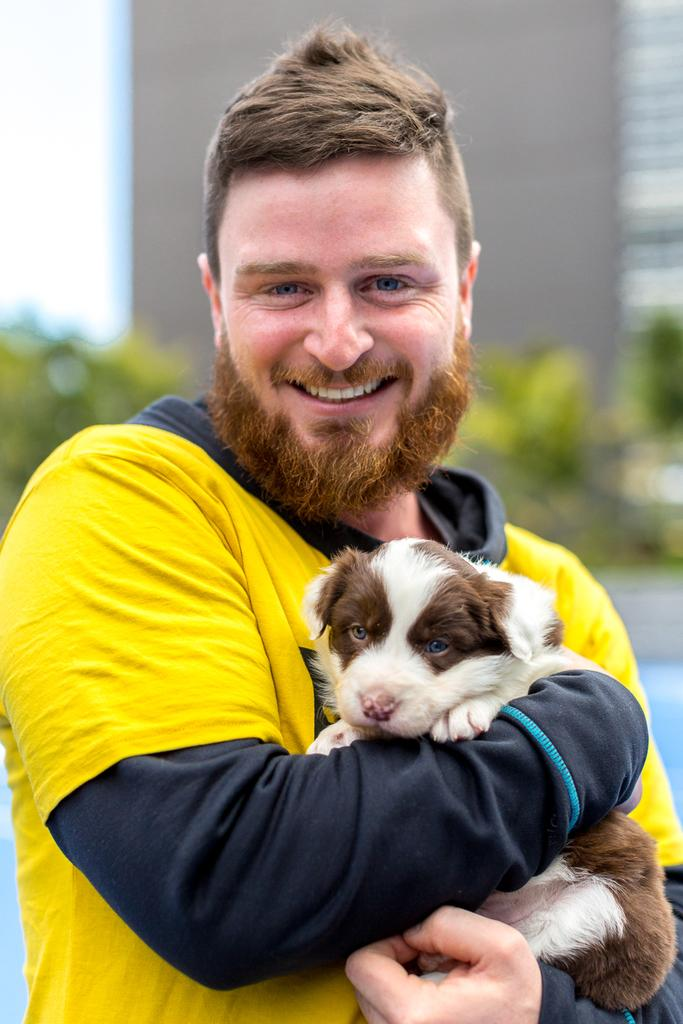What is the man in the image doing? The man is standing in the image and holding a dog. What is the man's facial expression in the image? The man is smiling in the image. What can be seen in the background of the image? There is a white color wall in the background of the image. What type of range can be seen in the image? There is no range present in the image. What things can be seen on the wall in the image? The wall in the image is white, and there are no visible things on it. 